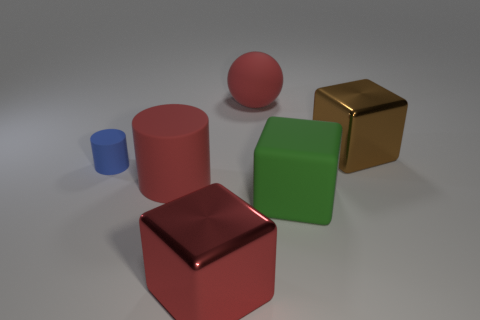Subtract all brown cubes. How many cubes are left? 2 Add 2 large yellow matte cubes. How many objects exist? 8 Subtract all cylinders. How many objects are left? 4 Subtract all matte cylinders. Subtract all green rubber blocks. How many objects are left? 3 Add 6 green things. How many green things are left? 7 Add 4 large cylinders. How many large cylinders exist? 5 Subtract 1 red cylinders. How many objects are left? 5 